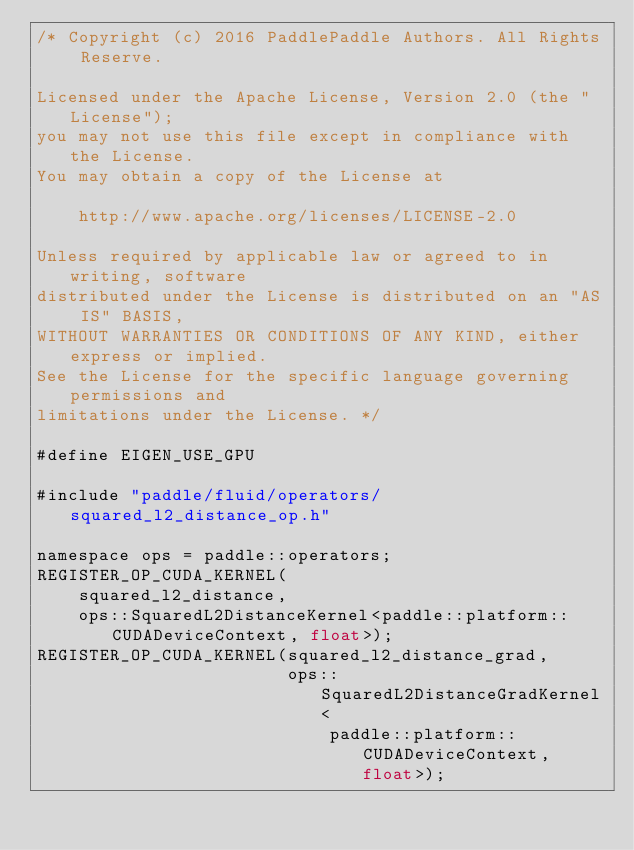Convert code to text. <code><loc_0><loc_0><loc_500><loc_500><_Cuda_>/* Copyright (c) 2016 PaddlePaddle Authors. All Rights Reserve.

Licensed under the Apache License, Version 2.0 (the "License");
you may not use this file except in compliance with the License.
You may obtain a copy of the License at

    http://www.apache.org/licenses/LICENSE-2.0

Unless required by applicable law or agreed to in writing, software
distributed under the License is distributed on an "AS IS" BASIS,
WITHOUT WARRANTIES OR CONDITIONS OF ANY KIND, either express or implied.
See the License for the specific language governing permissions and
limitations under the License. */

#define EIGEN_USE_GPU

#include "paddle/fluid/operators/squared_l2_distance_op.h"

namespace ops = paddle::operators;
REGISTER_OP_CUDA_KERNEL(
    squared_l2_distance,
    ops::SquaredL2DistanceKernel<paddle::platform::CUDADeviceContext, float>);
REGISTER_OP_CUDA_KERNEL(squared_l2_distance_grad,
                        ops::SquaredL2DistanceGradKernel<
                            paddle::platform::CUDADeviceContext, float>);
</code> 